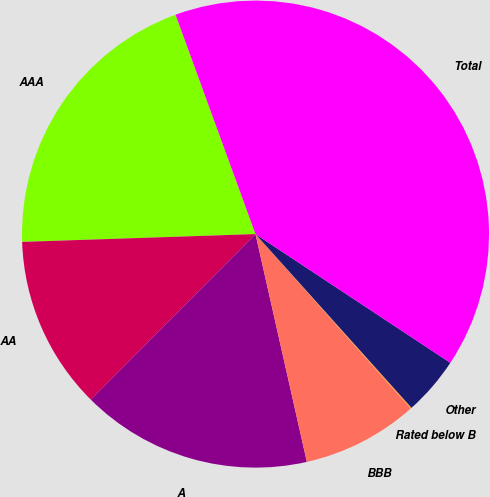Convert chart to OTSL. <chart><loc_0><loc_0><loc_500><loc_500><pie_chart><fcel>AAA<fcel>AA<fcel>A<fcel>BBB<fcel>Rated below B<fcel>Other<fcel>Total<nl><fcel>19.97%<fcel>12.01%<fcel>15.99%<fcel>8.04%<fcel>0.08%<fcel>4.06%<fcel>39.86%<nl></chart> 